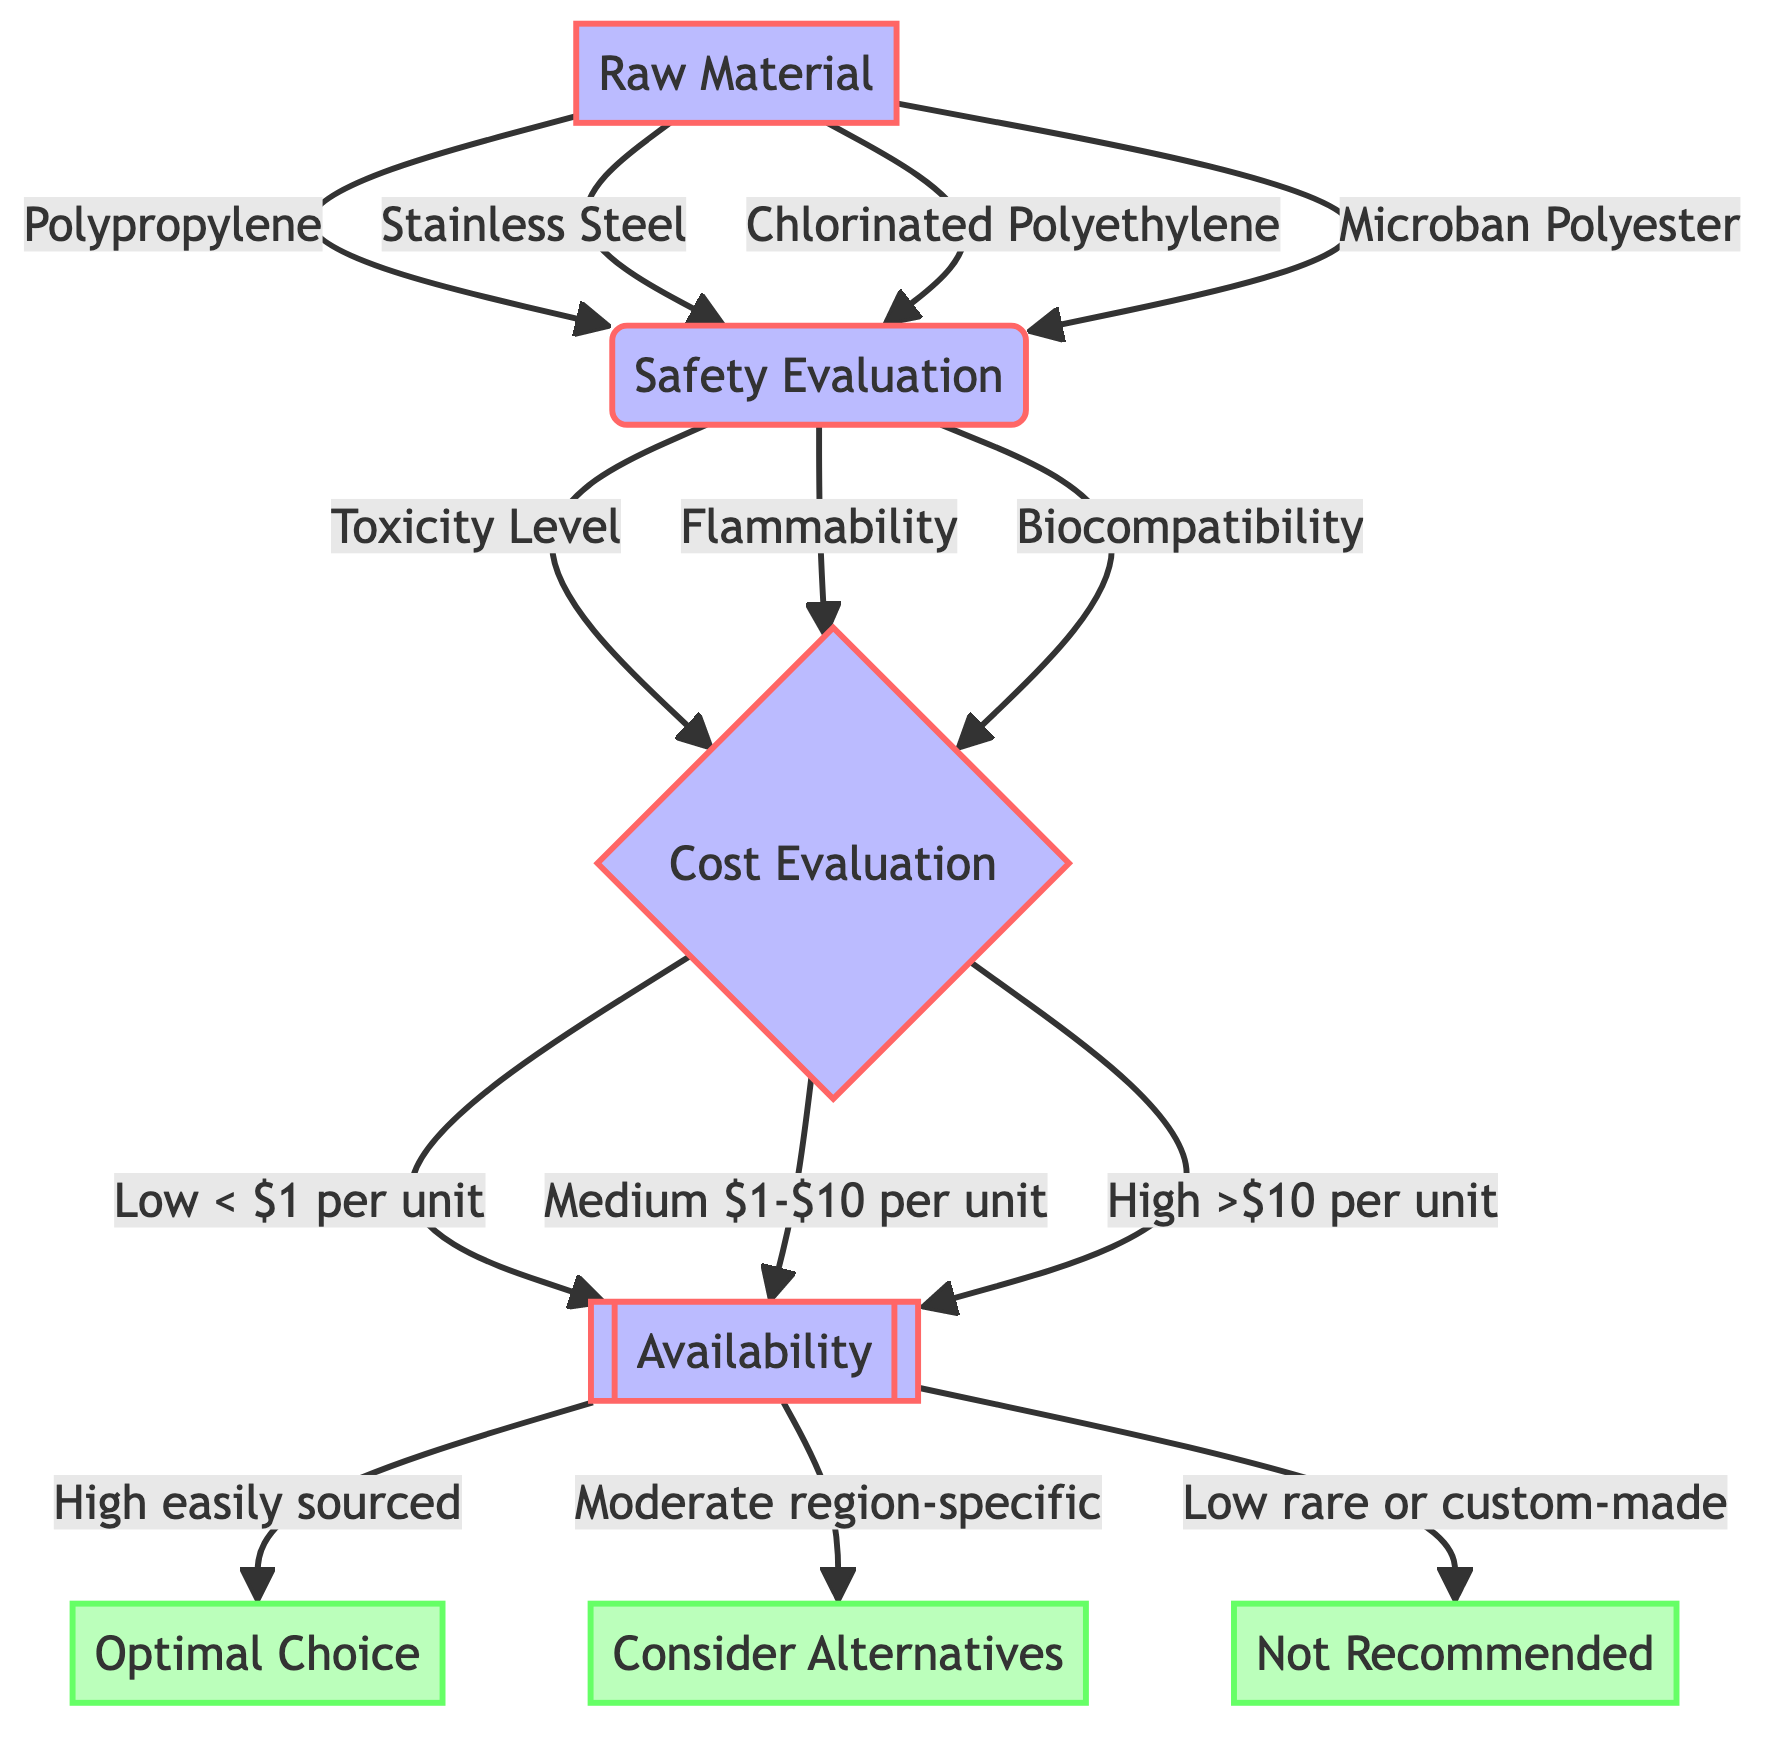What are the options for Raw Material? The diagram shows four options under the Raw Material decision node: Polypropylene, Stainless Steel, Chlorinated Polyethylene, and Microban Polyester.
Answer: Polypropylene, Stainless Steel, Chlorinated Polyethylene, Microban Polyester Which attribute follows after Safety Evaluation? After the Safety Evaluation node, the next attribute is Cost Evaluation, as shown in the flow of the diagram leading from Safety Evaluation to Cost Evaluation.
Answer: Cost Evaluation How many outcome options are presented? The diagram presents three outcomes in the final node after Availability: Optimal Choice, Consider Alternatives, and Not Recommended.
Answer: Three If the chosen Raw Material is Chlorinated Polyethylene and it is evaluated as Biocompatible, what is the possible outcome if it has Medium cost? Starting from Chlorinated Polyethylene leading to Safety Evaluation as Biocompatible, it then goes to the Cost Evaluation node and if the cost is Medium, it leads to the Availability node. Depending on the availability level, the possible outcomes can be Optimal Choice, Consider Alternatives, or Not Recommended.
Answer: Depends on Availability What happens if the Cost Evaluation is High? If the Cost Evaluation is High, it would lead to the Availability node, which then dictates the outcome based on the level of availability, possibly resulting in an Optimal Choice, Consider Alternatives, or Not Recommended outcome.
Answer: Depends on Availability How many branches does the Cost Evaluation node have? The Cost Evaluation node has three branches corresponding to the options: Low (< $1 per unit), Medium ($1-$10 per unit), and High (>$10 per unit).
Answer: Three Which Raw Material option leads to the same next node as Microban Polyester? Both Microban Polyester and the other options (Polypropylene, Stainless Steel, and Chlorinated Polyethylene) lead to the same next node, which is the Safety Evaluation node.
Answer: All options What is the outcome if the Availability is Low? If the Availability is Low (rare or custom-made), the outcome is explicitly stated in the diagram as "Not Recommended."
Answer: Not Recommended 